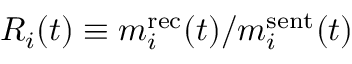<formula> <loc_0><loc_0><loc_500><loc_500>R _ { i } ( t ) \equiv m _ { i } ^ { r e c } ( t ) / m _ { i } ^ { s e n t } ( t )</formula> 